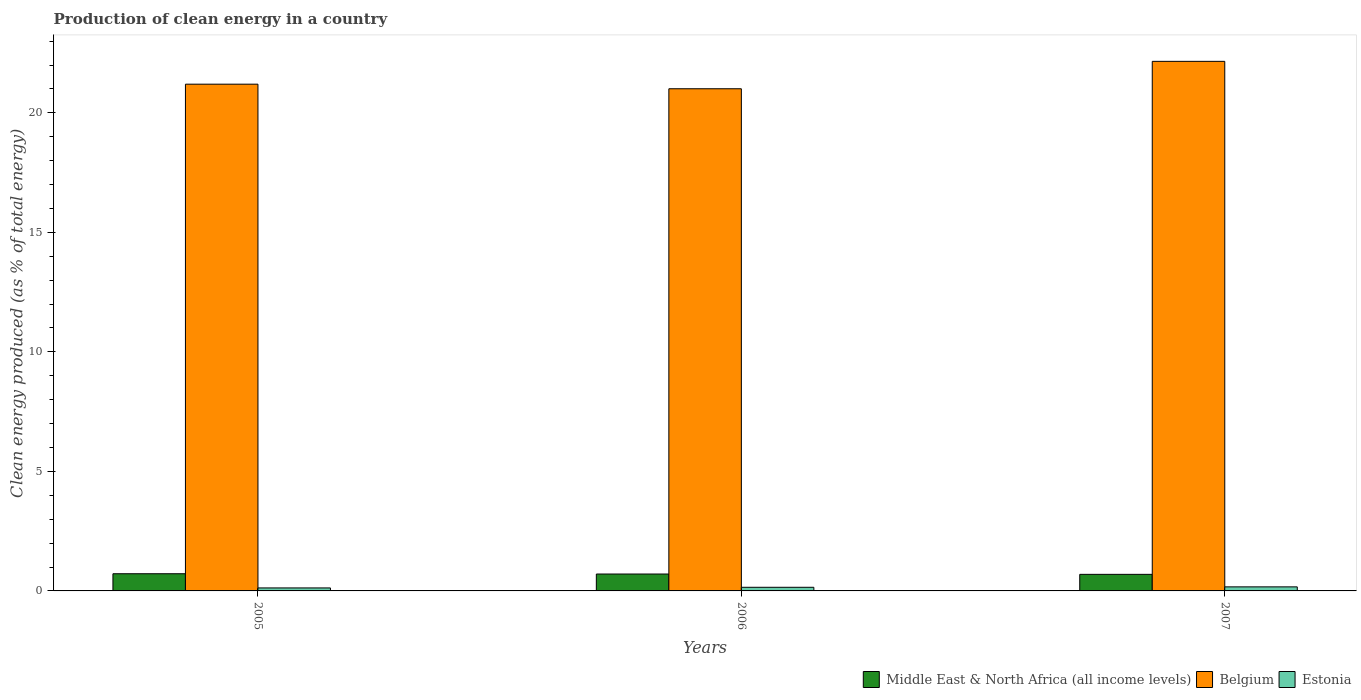How many different coloured bars are there?
Keep it short and to the point. 3. How many groups of bars are there?
Provide a succinct answer. 3. Are the number of bars per tick equal to the number of legend labels?
Keep it short and to the point. Yes. How many bars are there on the 2nd tick from the left?
Your answer should be very brief. 3. How many bars are there on the 1st tick from the right?
Your response must be concise. 3. What is the label of the 1st group of bars from the left?
Provide a short and direct response. 2005. What is the percentage of clean energy produced in Belgium in 2006?
Make the answer very short. 21.01. Across all years, what is the maximum percentage of clean energy produced in Estonia?
Make the answer very short. 0.17. Across all years, what is the minimum percentage of clean energy produced in Estonia?
Your answer should be compact. 0.13. In which year was the percentage of clean energy produced in Estonia maximum?
Offer a very short reply. 2007. What is the total percentage of clean energy produced in Middle East & North Africa (all income levels) in the graph?
Keep it short and to the point. 2.12. What is the difference between the percentage of clean energy produced in Middle East & North Africa (all income levels) in 2005 and that in 2006?
Provide a short and direct response. 0.01. What is the difference between the percentage of clean energy produced in Estonia in 2007 and the percentage of clean energy produced in Belgium in 2006?
Ensure brevity in your answer.  -20.84. What is the average percentage of clean energy produced in Middle East & North Africa (all income levels) per year?
Provide a short and direct response. 0.71. In the year 2006, what is the difference between the percentage of clean energy produced in Belgium and percentage of clean energy produced in Estonia?
Offer a very short reply. 20.86. What is the ratio of the percentage of clean energy produced in Belgium in 2005 to that in 2006?
Offer a terse response. 1.01. Is the difference between the percentage of clean energy produced in Belgium in 2005 and 2006 greater than the difference between the percentage of clean energy produced in Estonia in 2005 and 2006?
Provide a succinct answer. Yes. What is the difference between the highest and the second highest percentage of clean energy produced in Middle East & North Africa (all income levels)?
Offer a very short reply. 0.01. What is the difference between the highest and the lowest percentage of clean energy produced in Estonia?
Keep it short and to the point. 0.04. In how many years, is the percentage of clean energy produced in Middle East & North Africa (all income levels) greater than the average percentage of clean energy produced in Middle East & North Africa (all income levels) taken over all years?
Provide a short and direct response. 2. Is the sum of the percentage of clean energy produced in Belgium in 2005 and 2006 greater than the maximum percentage of clean energy produced in Middle East & North Africa (all income levels) across all years?
Your response must be concise. Yes. What does the 3rd bar from the right in 2007 represents?
Keep it short and to the point. Middle East & North Africa (all income levels). Is it the case that in every year, the sum of the percentage of clean energy produced in Estonia and percentage of clean energy produced in Middle East & North Africa (all income levels) is greater than the percentage of clean energy produced in Belgium?
Offer a terse response. No. How many years are there in the graph?
Offer a terse response. 3. Does the graph contain grids?
Keep it short and to the point. No. Where does the legend appear in the graph?
Your answer should be very brief. Bottom right. How many legend labels are there?
Your answer should be compact. 3. What is the title of the graph?
Provide a short and direct response. Production of clean energy in a country. Does "Marshall Islands" appear as one of the legend labels in the graph?
Provide a short and direct response. No. What is the label or title of the X-axis?
Ensure brevity in your answer.  Years. What is the label or title of the Y-axis?
Keep it short and to the point. Clean energy produced (as % of total energy). What is the Clean energy produced (as % of total energy) of Middle East & North Africa (all income levels) in 2005?
Ensure brevity in your answer.  0.72. What is the Clean energy produced (as % of total energy) in Belgium in 2005?
Provide a succinct answer. 21.2. What is the Clean energy produced (as % of total energy) of Estonia in 2005?
Provide a short and direct response. 0.13. What is the Clean energy produced (as % of total energy) in Middle East & North Africa (all income levels) in 2006?
Offer a very short reply. 0.71. What is the Clean energy produced (as % of total energy) of Belgium in 2006?
Offer a very short reply. 21.01. What is the Clean energy produced (as % of total energy) in Estonia in 2006?
Keep it short and to the point. 0.15. What is the Clean energy produced (as % of total energy) of Middle East & North Africa (all income levels) in 2007?
Give a very brief answer. 0.69. What is the Clean energy produced (as % of total energy) in Belgium in 2007?
Your answer should be very brief. 22.15. What is the Clean energy produced (as % of total energy) of Estonia in 2007?
Keep it short and to the point. 0.17. Across all years, what is the maximum Clean energy produced (as % of total energy) of Middle East & North Africa (all income levels)?
Ensure brevity in your answer.  0.72. Across all years, what is the maximum Clean energy produced (as % of total energy) in Belgium?
Your answer should be compact. 22.15. Across all years, what is the maximum Clean energy produced (as % of total energy) of Estonia?
Make the answer very short. 0.17. Across all years, what is the minimum Clean energy produced (as % of total energy) in Middle East & North Africa (all income levels)?
Your response must be concise. 0.69. Across all years, what is the minimum Clean energy produced (as % of total energy) of Belgium?
Keep it short and to the point. 21.01. Across all years, what is the minimum Clean energy produced (as % of total energy) in Estonia?
Keep it short and to the point. 0.13. What is the total Clean energy produced (as % of total energy) in Middle East & North Africa (all income levels) in the graph?
Offer a terse response. 2.12. What is the total Clean energy produced (as % of total energy) of Belgium in the graph?
Give a very brief answer. 64.36. What is the total Clean energy produced (as % of total energy) of Estonia in the graph?
Your answer should be compact. 0.45. What is the difference between the Clean energy produced (as % of total energy) of Middle East & North Africa (all income levels) in 2005 and that in 2006?
Provide a succinct answer. 0.01. What is the difference between the Clean energy produced (as % of total energy) of Belgium in 2005 and that in 2006?
Ensure brevity in your answer.  0.19. What is the difference between the Clean energy produced (as % of total energy) of Estonia in 2005 and that in 2006?
Your answer should be compact. -0.03. What is the difference between the Clean energy produced (as % of total energy) in Middle East & North Africa (all income levels) in 2005 and that in 2007?
Provide a short and direct response. 0.03. What is the difference between the Clean energy produced (as % of total energy) in Belgium in 2005 and that in 2007?
Your response must be concise. -0.96. What is the difference between the Clean energy produced (as % of total energy) of Estonia in 2005 and that in 2007?
Your answer should be very brief. -0.04. What is the difference between the Clean energy produced (as % of total energy) of Middle East & North Africa (all income levels) in 2006 and that in 2007?
Offer a terse response. 0.01. What is the difference between the Clean energy produced (as % of total energy) in Belgium in 2006 and that in 2007?
Make the answer very short. -1.15. What is the difference between the Clean energy produced (as % of total energy) in Estonia in 2006 and that in 2007?
Offer a very short reply. -0.02. What is the difference between the Clean energy produced (as % of total energy) in Middle East & North Africa (all income levels) in 2005 and the Clean energy produced (as % of total energy) in Belgium in 2006?
Give a very brief answer. -20.29. What is the difference between the Clean energy produced (as % of total energy) of Middle East & North Africa (all income levels) in 2005 and the Clean energy produced (as % of total energy) of Estonia in 2006?
Your response must be concise. 0.57. What is the difference between the Clean energy produced (as % of total energy) in Belgium in 2005 and the Clean energy produced (as % of total energy) in Estonia in 2006?
Give a very brief answer. 21.05. What is the difference between the Clean energy produced (as % of total energy) of Middle East & North Africa (all income levels) in 2005 and the Clean energy produced (as % of total energy) of Belgium in 2007?
Give a very brief answer. -21.44. What is the difference between the Clean energy produced (as % of total energy) in Middle East & North Africa (all income levels) in 2005 and the Clean energy produced (as % of total energy) in Estonia in 2007?
Provide a short and direct response. 0.55. What is the difference between the Clean energy produced (as % of total energy) in Belgium in 2005 and the Clean energy produced (as % of total energy) in Estonia in 2007?
Your answer should be compact. 21.03. What is the difference between the Clean energy produced (as % of total energy) in Middle East & North Africa (all income levels) in 2006 and the Clean energy produced (as % of total energy) in Belgium in 2007?
Provide a succinct answer. -21.45. What is the difference between the Clean energy produced (as % of total energy) of Middle East & North Africa (all income levels) in 2006 and the Clean energy produced (as % of total energy) of Estonia in 2007?
Offer a very short reply. 0.54. What is the difference between the Clean energy produced (as % of total energy) in Belgium in 2006 and the Clean energy produced (as % of total energy) in Estonia in 2007?
Ensure brevity in your answer.  20.84. What is the average Clean energy produced (as % of total energy) of Middle East & North Africa (all income levels) per year?
Ensure brevity in your answer.  0.71. What is the average Clean energy produced (as % of total energy) of Belgium per year?
Give a very brief answer. 21.45. What is the average Clean energy produced (as % of total energy) of Estonia per year?
Your answer should be very brief. 0.15. In the year 2005, what is the difference between the Clean energy produced (as % of total energy) of Middle East & North Africa (all income levels) and Clean energy produced (as % of total energy) of Belgium?
Offer a terse response. -20.48. In the year 2005, what is the difference between the Clean energy produced (as % of total energy) of Middle East & North Africa (all income levels) and Clean energy produced (as % of total energy) of Estonia?
Offer a terse response. 0.59. In the year 2005, what is the difference between the Clean energy produced (as % of total energy) in Belgium and Clean energy produced (as % of total energy) in Estonia?
Your answer should be very brief. 21.07. In the year 2006, what is the difference between the Clean energy produced (as % of total energy) of Middle East & North Africa (all income levels) and Clean energy produced (as % of total energy) of Belgium?
Keep it short and to the point. -20.3. In the year 2006, what is the difference between the Clean energy produced (as % of total energy) in Middle East & North Africa (all income levels) and Clean energy produced (as % of total energy) in Estonia?
Your answer should be very brief. 0.55. In the year 2006, what is the difference between the Clean energy produced (as % of total energy) of Belgium and Clean energy produced (as % of total energy) of Estonia?
Ensure brevity in your answer.  20.86. In the year 2007, what is the difference between the Clean energy produced (as % of total energy) in Middle East & North Africa (all income levels) and Clean energy produced (as % of total energy) in Belgium?
Give a very brief answer. -21.46. In the year 2007, what is the difference between the Clean energy produced (as % of total energy) in Middle East & North Africa (all income levels) and Clean energy produced (as % of total energy) in Estonia?
Keep it short and to the point. 0.52. In the year 2007, what is the difference between the Clean energy produced (as % of total energy) of Belgium and Clean energy produced (as % of total energy) of Estonia?
Provide a short and direct response. 21.99. What is the ratio of the Clean energy produced (as % of total energy) in Middle East & North Africa (all income levels) in 2005 to that in 2006?
Your response must be concise. 1.02. What is the ratio of the Clean energy produced (as % of total energy) in Belgium in 2005 to that in 2006?
Keep it short and to the point. 1.01. What is the ratio of the Clean energy produced (as % of total energy) in Estonia in 2005 to that in 2006?
Offer a very short reply. 0.82. What is the ratio of the Clean energy produced (as % of total energy) in Middle East & North Africa (all income levels) in 2005 to that in 2007?
Your answer should be compact. 1.04. What is the ratio of the Clean energy produced (as % of total energy) in Belgium in 2005 to that in 2007?
Offer a terse response. 0.96. What is the ratio of the Clean energy produced (as % of total energy) of Estonia in 2005 to that in 2007?
Offer a very short reply. 0.74. What is the ratio of the Clean energy produced (as % of total energy) of Middle East & North Africa (all income levels) in 2006 to that in 2007?
Keep it short and to the point. 1.02. What is the ratio of the Clean energy produced (as % of total energy) of Belgium in 2006 to that in 2007?
Ensure brevity in your answer.  0.95. What is the ratio of the Clean energy produced (as % of total energy) of Estonia in 2006 to that in 2007?
Offer a terse response. 0.9. What is the difference between the highest and the second highest Clean energy produced (as % of total energy) in Middle East & North Africa (all income levels)?
Offer a terse response. 0.01. What is the difference between the highest and the second highest Clean energy produced (as % of total energy) of Belgium?
Provide a short and direct response. 0.96. What is the difference between the highest and the second highest Clean energy produced (as % of total energy) in Estonia?
Provide a short and direct response. 0.02. What is the difference between the highest and the lowest Clean energy produced (as % of total energy) of Middle East & North Africa (all income levels)?
Your response must be concise. 0.03. What is the difference between the highest and the lowest Clean energy produced (as % of total energy) of Belgium?
Provide a succinct answer. 1.15. What is the difference between the highest and the lowest Clean energy produced (as % of total energy) of Estonia?
Your answer should be very brief. 0.04. 